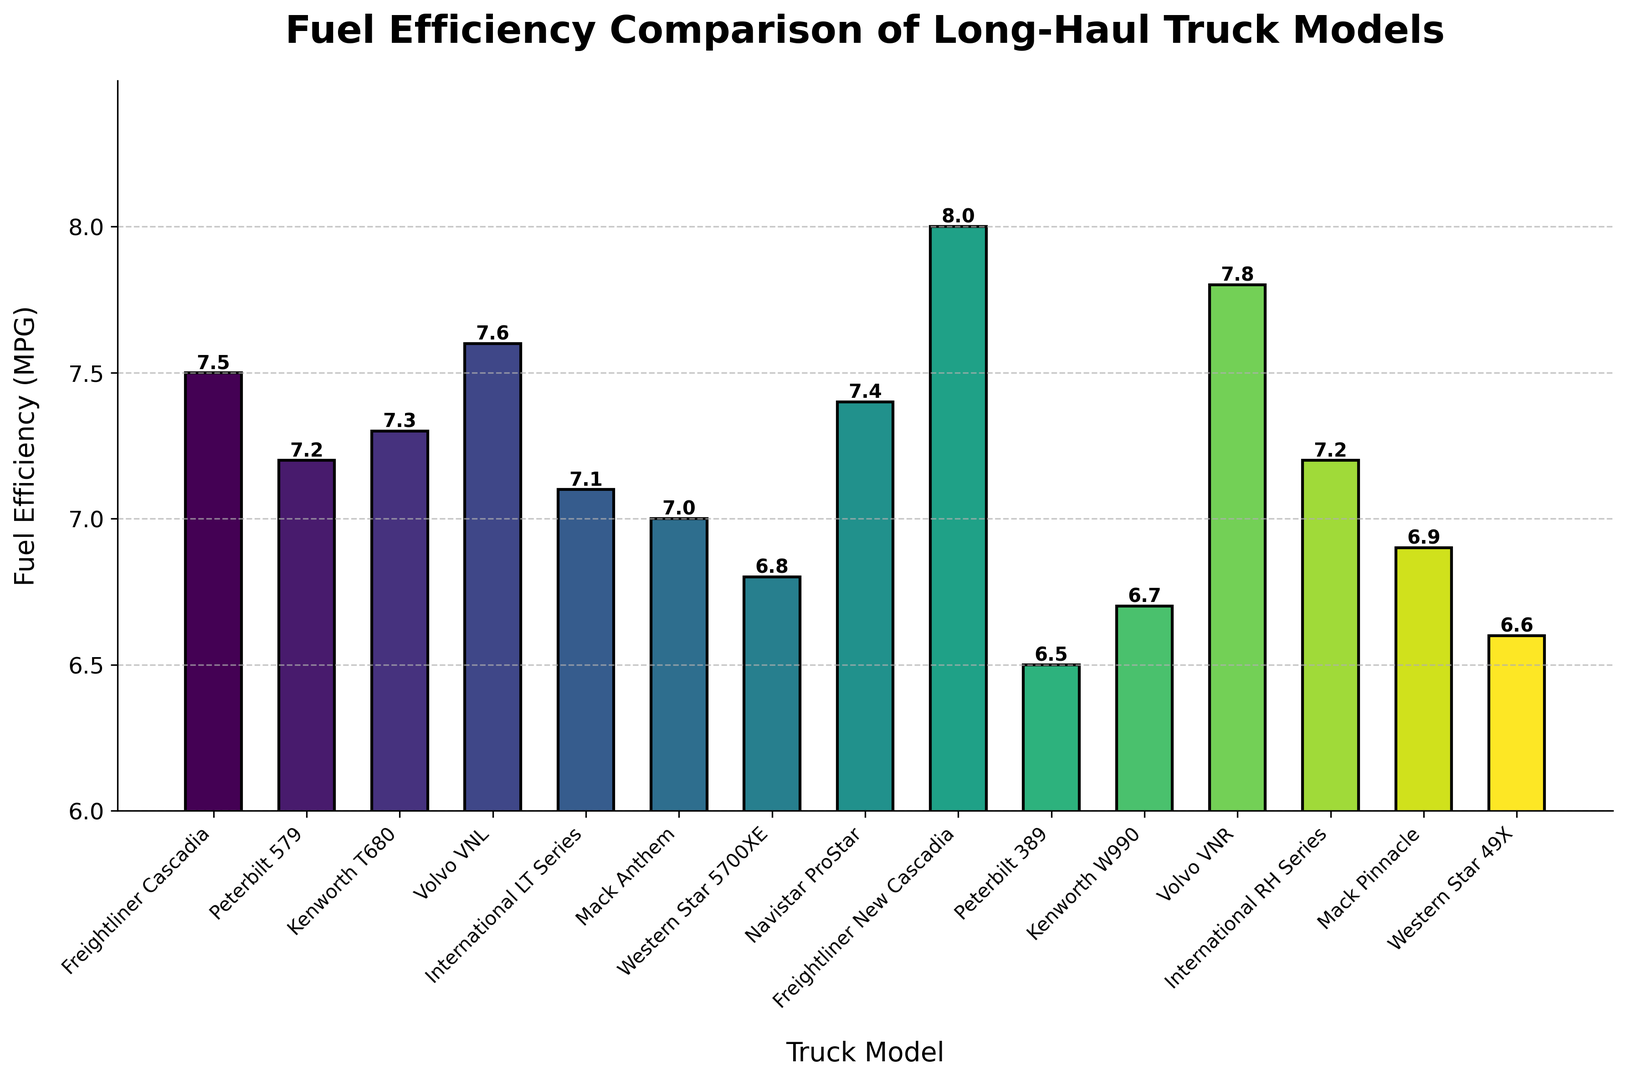What's the most fuel-efficient truck model? The most fuel-efficient truck model is the one with the highest bar. Looking at the heights of the bars, the Freightliner New Cascadia has the highest bar.
Answer: Freightliner New Cascadia Which truck model has the least fuel efficiency? The truck model with the least fuel efficiency will have the shortest bar. The Peterbilt 389 has the shortest bar among all the models shown.
Answer: Peterbilt 389 What is the difference in fuel efficiency between the Volvo VNR and the Mack Anthem? The fuel efficiency of the Volvo VNR is 7.8 MPG, and for the Mack Anthem, it's 7.0 MPG. The difference can be calculated as 7.8 - 7.0 = 0.8 MPG.
Answer: 0.8 MPG How many truck models have fuel efficiencies greater than 7.5 MPG? By looking at the figure, the bars for the Volvo VNL, Freightliner New Cascadia, and Volvo VNR are above the 7.5 MPG mark. So there are three models.
Answer: 3 What is the average fuel efficiency of the three Peterbilt models listed? The fuel efficiencies for the Peterbilt 579, Peterbilt 389, and Peterbilt 579 are 7.2, 6.5, and 7.2 MPG respectively. The average can be calculated by (7.2 + 6.5 + 7.2) / 3 = 6.97 MPG.
Answer: 6.97 MPG Among the two International models, which one has better fuel efficiency, and by how much? The International LT Series has 7.1 MPG, and the International RH Series has 7.2 MPG. Thus, the International RH Series is more efficient by 7.2 - 7.1 = 0.1 MPG.
Answer: International RH Series, 0.1 MPG Which truck models have a fuel efficiency between 6.5 and 7.0 MPG? By examining the bars, the Peterbilt 389 (6.5 MPG), Kenworth W990 (6.7 MPG), Western Star 49X (6.6 MPG), and Mack Pinnacle (6.9 MPG) fall within the range of 6.5 to 7.0 MPG.
Answer: Peterbilt 389, Kenworth W990, Western Star 49X, Mack Pinnacle If you were to combine the fuel efficiencies of the Freightliner Cascadia and the Navistar ProStar, what would be the total? The fuel efficiency for the Freightliner Cascadia is 7.5 MPG, and for the Navistar ProStar, it is 7.4 MPG. Combined, they total 7.5 + 7.4 = 14.9 MPG.
Answer: 14.9 MPG What is the median fuel efficiency of all the listed truck models? First, list the fuel efficiencies in ascending order: 6.5, 6.6, 6.7, 6.8, 6.9, 7.0, 7.1, 7.2, 7.2, 7.3, 7.4, 7.5, 7.6, 7.8, 8.0. The middle value in this 15-number list is the 8th value, which is 7.2 MPG.
Answer: 7.2 MPG Which has a higher fuel efficiency: the average of all Kenworth models or the Western Star 5700XE? The Kenworth models listed are Kenworth T680 (7.3 MPG) and Kenworth W990 (6.7 MPG). Their average is (7.3 + 6.7) / 2 = 7.0 MPG. The Western Star 5700XE has a fuel efficiency of 6.8 MPG, so the average of the Kenworth models is higher.
Answer: Kenworth models 